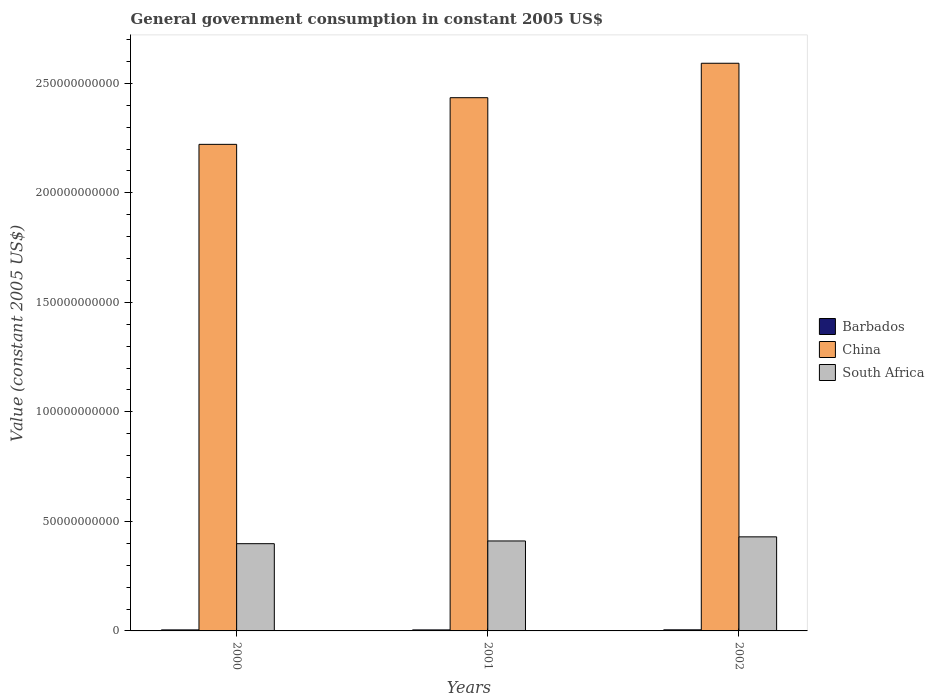How many groups of bars are there?
Your answer should be compact. 3. How many bars are there on the 1st tick from the right?
Give a very brief answer. 3. What is the government conusmption in China in 2002?
Ensure brevity in your answer.  2.59e+11. Across all years, what is the maximum government conusmption in Barbados?
Offer a terse response. 4.97e+08. Across all years, what is the minimum government conusmption in Barbados?
Your response must be concise. 4.63e+08. In which year was the government conusmption in South Africa maximum?
Your response must be concise. 2002. What is the total government conusmption in China in the graph?
Provide a short and direct response. 7.25e+11. What is the difference between the government conusmption in South Africa in 2000 and that in 2001?
Ensure brevity in your answer.  -1.24e+09. What is the difference between the government conusmption in South Africa in 2000 and the government conusmption in Barbados in 2001?
Your response must be concise. 3.94e+1. What is the average government conusmption in South Africa per year?
Offer a terse response. 4.13e+1. In the year 2000, what is the difference between the government conusmption in China and government conusmption in Barbados?
Give a very brief answer. 2.22e+11. What is the ratio of the government conusmption in Barbados in 2000 to that in 2002?
Your answer should be compact. 0.94. Is the government conusmption in China in 2000 less than that in 2002?
Make the answer very short. Yes. Is the difference between the government conusmption in China in 2001 and 2002 greater than the difference between the government conusmption in Barbados in 2001 and 2002?
Give a very brief answer. No. What is the difference between the highest and the second highest government conusmption in South Africa?
Your answer should be compact. 1.88e+09. What is the difference between the highest and the lowest government conusmption in China?
Offer a very short reply. 3.70e+1. In how many years, is the government conusmption in South Africa greater than the average government conusmption in South Africa taken over all years?
Your answer should be compact. 1. Is the sum of the government conusmption in South Africa in 2000 and 2001 greater than the maximum government conusmption in China across all years?
Give a very brief answer. No. What does the 1st bar from the left in 2002 represents?
Provide a succinct answer. Barbados. What does the 3rd bar from the right in 2001 represents?
Give a very brief answer. Barbados. Is it the case that in every year, the sum of the government conusmption in South Africa and government conusmption in Barbados is greater than the government conusmption in China?
Your answer should be very brief. No. How many bars are there?
Make the answer very short. 9. How many years are there in the graph?
Provide a succinct answer. 3. Are the values on the major ticks of Y-axis written in scientific E-notation?
Provide a succinct answer. No. Does the graph contain any zero values?
Your response must be concise. No. Does the graph contain grids?
Provide a short and direct response. No. How many legend labels are there?
Give a very brief answer. 3. What is the title of the graph?
Your response must be concise. General government consumption in constant 2005 US$. Does "Euro area" appear as one of the legend labels in the graph?
Provide a succinct answer. No. What is the label or title of the Y-axis?
Provide a short and direct response. Value (constant 2005 US$). What is the Value (constant 2005 US$) in Barbados in 2000?
Provide a succinct answer. 4.65e+08. What is the Value (constant 2005 US$) of China in 2000?
Offer a terse response. 2.22e+11. What is the Value (constant 2005 US$) of South Africa in 2000?
Ensure brevity in your answer.  3.98e+1. What is the Value (constant 2005 US$) in Barbados in 2001?
Make the answer very short. 4.63e+08. What is the Value (constant 2005 US$) of China in 2001?
Your answer should be very brief. 2.43e+11. What is the Value (constant 2005 US$) in South Africa in 2001?
Make the answer very short. 4.11e+1. What is the Value (constant 2005 US$) in Barbados in 2002?
Your answer should be compact. 4.97e+08. What is the Value (constant 2005 US$) in China in 2002?
Make the answer very short. 2.59e+11. What is the Value (constant 2005 US$) in South Africa in 2002?
Your response must be concise. 4.29e+1. Across all years, what is the maximum Value (constant 2005 US$) in Barbados?
Your response must be concise. 4.97e+08. Across all years, what is the maximum Value (constant 2005 US$) in China?
Provide a short and direct response. 2.59e+11. Across all years, what is the maximum Value (constant 2005 US$) of South Africa?
Ensure brevity in your answer.  4.29e+1. Across all years, what is the minimum Value (constant 2005 US$) in Barbados?
Ensure brevity in your answer.  4.63e+08. Across all years, what is the minimum Value (constant 2005 US$) of China?
Your response must be concise. 2.22e+11. Across all years, what is the minimum Value (constant 2005 US$) of South Africa?
Provide a short and direct response. 3.98e+1. What is the total Value (constant 2005 US$) in Barbados in the graph?
Offer a terse response. 1.42e+09. What is the total Value (constant 2005 US$) in China in the graph?
Your response must be concise. 7.25e+11. What is the total Value (constant 2005 US$) in South Africa in the graph?
Provide a succinct answer. 1.24e+11. What is the difference between the Value (constant 2005 US$) in Barbados in 2000 and that in 2001?
Make the answer very short. 2.44e+06. What is the difference between the Value (constant 2005 US$) of China in 2000 and that in 2001?
Offer a terse response. -2.13e+1. What is the difference between the Value (constant 2005 US$) in South Africa in 2000 and that in 2001?
Keep it short and to the point. -1.24e+09. What is the difference between the Value (constant 2005 US$) in Barbados in 2000 and that in 2002?
Offer a very short reply. -3.17e+07. What is the difference between the Value (constant 2005 US$) in China in 2000 and that in 2002?
Provide a short and direct response. -3.70e+1. What is the difference between the Value (constant 2005 US$) of South Africa in 2000 and that in 2002?
Provide a short and direct response. -3.12e+09. What is the difference between the Value (constant 2005 US$) in Barbados in 2001 and that in 2002?
Give a very brief answer. -3.41e+07. What is the difference between the Value (constant 2005 US$) in China in 2001 and that in 2002?
Offer a terse response. -1.57e+1. What is the difference between the Value (constant 2005 US$) of South Africa in 2001 and that in 2002?
Ensure brevity in your answer.  -1.88e+09. What is the difference between the Value (constant 2005 US$) in Barbados in 2000 and the Value (constant 2005 US$) in China in 2001?
Offer a terse response. -2.43e+11. What is the difference between the Value (constant 2005 US$) of Barbados in 2000 and the Value (constant 2005 US$) of South Africa in 2001?
Offer a very short reply. -4.06e+1. What is the difference between the Value (constant 2005 US$) in China in 2000 and the Value (constant 2005 US$) in South Africa in 2001?
Give a very brief answer. 1.81e+11. What is the difference between the Value (constant 2005 US$) in Barbados in 2000 and the Value (constant 2005 US$) in China in 2002?
Make the answer very short. -2.59e+11. What is the difference between the Value (constant 2005 US$) of Barbados in 2000 and the Value (constant 2005 US$) of South Africa in 2002?
Give a very brief answer. -4.25e+1. What is the difference between the Value (constant 2005 US$) in China in 2000 and the Value (constant 2005 US$) in South Africa in 2002?
Keep it short and to the point. 1.79e+11. What is the difference between the Value (constant 2005 US$) of Barbados in 2001 and the Value (constant 2005 US$) of China in 2002?
Your response must be concise. -2.59e+11. What is the difference between the Value (constant 2005 US$) in Barbados in 2001 and the Value (constant 2005 US$) in South Africa in 2002?
Make the answer very short. -4.25e+1. What is the difference between the Value (constant 2005 US$) in China in 2001 and the Value (constant 2005 US$) in South Africa in 2002?
Make the answer very short. 2.00e+11. What is the average Value (constant 2005 US$) of Barbados per year?
Give a very brief answer. 4.75e+08. What is the average Value (constant 2005 US$) of China per year?
Make the answer very short. 2.42e+11. What is the average Value (constant 2005 US$) of South Africa per year?
Your response must be concise. 4.13e+1. In the year 2000, what is the difference between the Value (constant 2005 US$) of Barbados and Value (constant 2005 US$) of China?
Give a very brief answer. -2.22e+11. In the year 2000, what is the difference between the Value (constant 2005 US$) of Barbados and Value (constant 2005 US$) of South Africa?
Your answer should be very brief. -3.94e+1. In the year 2000, what is the difference between the Value (constant 2005 US$) in China and Value (constant 2005 US$) in South Africa?
Keep it short and to the point. 1.82e+11. In the year 2001, what is the difference between the Value (constant 2005 US$) in Barbados and Value (constant 2005 US$) in China?
Your answer should be very brief. -2.43e+11. In the year 2001, what is the difference between the Value (constant 2005 US$) in Barbados and Value (constant 2005 US$) in South Africa?
Your response must be concise. -4.06e+1. In the year 2001, what is the difference between the Value (constant 2005 US$) in China and Value (constant 2005 US$) in South Africa?
Your response must be concise. 2.02e+11. In the year 2002, what is the difference between the Value (constant 2005 US$) of Barbados and Value (constant 2005 US$) of China?
Give a very brief answer. -2.59e+11. In the year 2002, what is the difference between the Value (constant 2005 US$) of Barbados and Value (constant 2005 US$) of South Africa?
Your answer should be compact. -4.25e+1. In the year 2002, what is the difference between the Value (constant 2005 US$) in China and Value (constant 2005 US$) in South Africa?
Offer a very short reply. 2.16e+11. What is the ratio of the Value (constant 2005 US$) of China in 2000 to that in 2001?
Make the answer very short. 0.91. What is the ratio of the Value (constant 2005 US$) in South Africa in 2000 to that in 2001?
Your answer should be very brief. 0.97. What is the ratio of the Value (constant 2005 US$) of Barbados in 2000 to that in 2002?
Your answer should be compact. 0.94. What is the ratio of the Value (constant 2005 US$) in South Africa in 2000 to that in 2002?
Ensure brevity in your answer.  0.93. What is the ratio of the Value (constant 2005 US$) in Barbados in 2001 to that in 2002?
Offer a very short reply. 0.93. What is the ratio of the Value (constant 2005 US$) of China in 2001 to that in 2002?
Make the answer very short. 0.94. What is the ratio of the Value (constant 2005 US$) of South Africa in 2001 to that in 2002?
Your response must be concise. 0.96. What is the difference between the highest and the second highest Value (constant 2005 US$) of Barbados?
Make the answer very short. 3.17e+07. What is the difference between the highest and the second highest Value (constant 2005 US$) of China?
Your answer should be compact. 1.57e+1. What is the difference between the highest and the second highest Value (constant 2005 US$) in South Africa?
Keep it short and to the point. 1.88e+09. What is the difference between the highest and the lowest Value (constant 2005 US$) in Barbados?
Your response must be concise. 3.41e+07. What is the difference between the highest and the lowest Value (constant 2005 US$) of China?
Offer a terse response. 3.70e+1. What is the difference between the highest and the lowest Value (constant 2005 US$) in South Africa?
Offer a very short reply. 3.12e+09. 